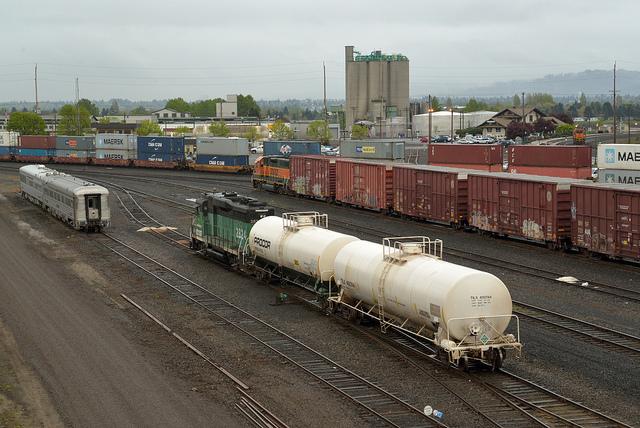What railroad company has the orange and black engine?
Short answer required. Can't tell. Is this train carrying liquid?
Answer briefly. Yes. How many tracks are there?
Keep it brief. 4. 